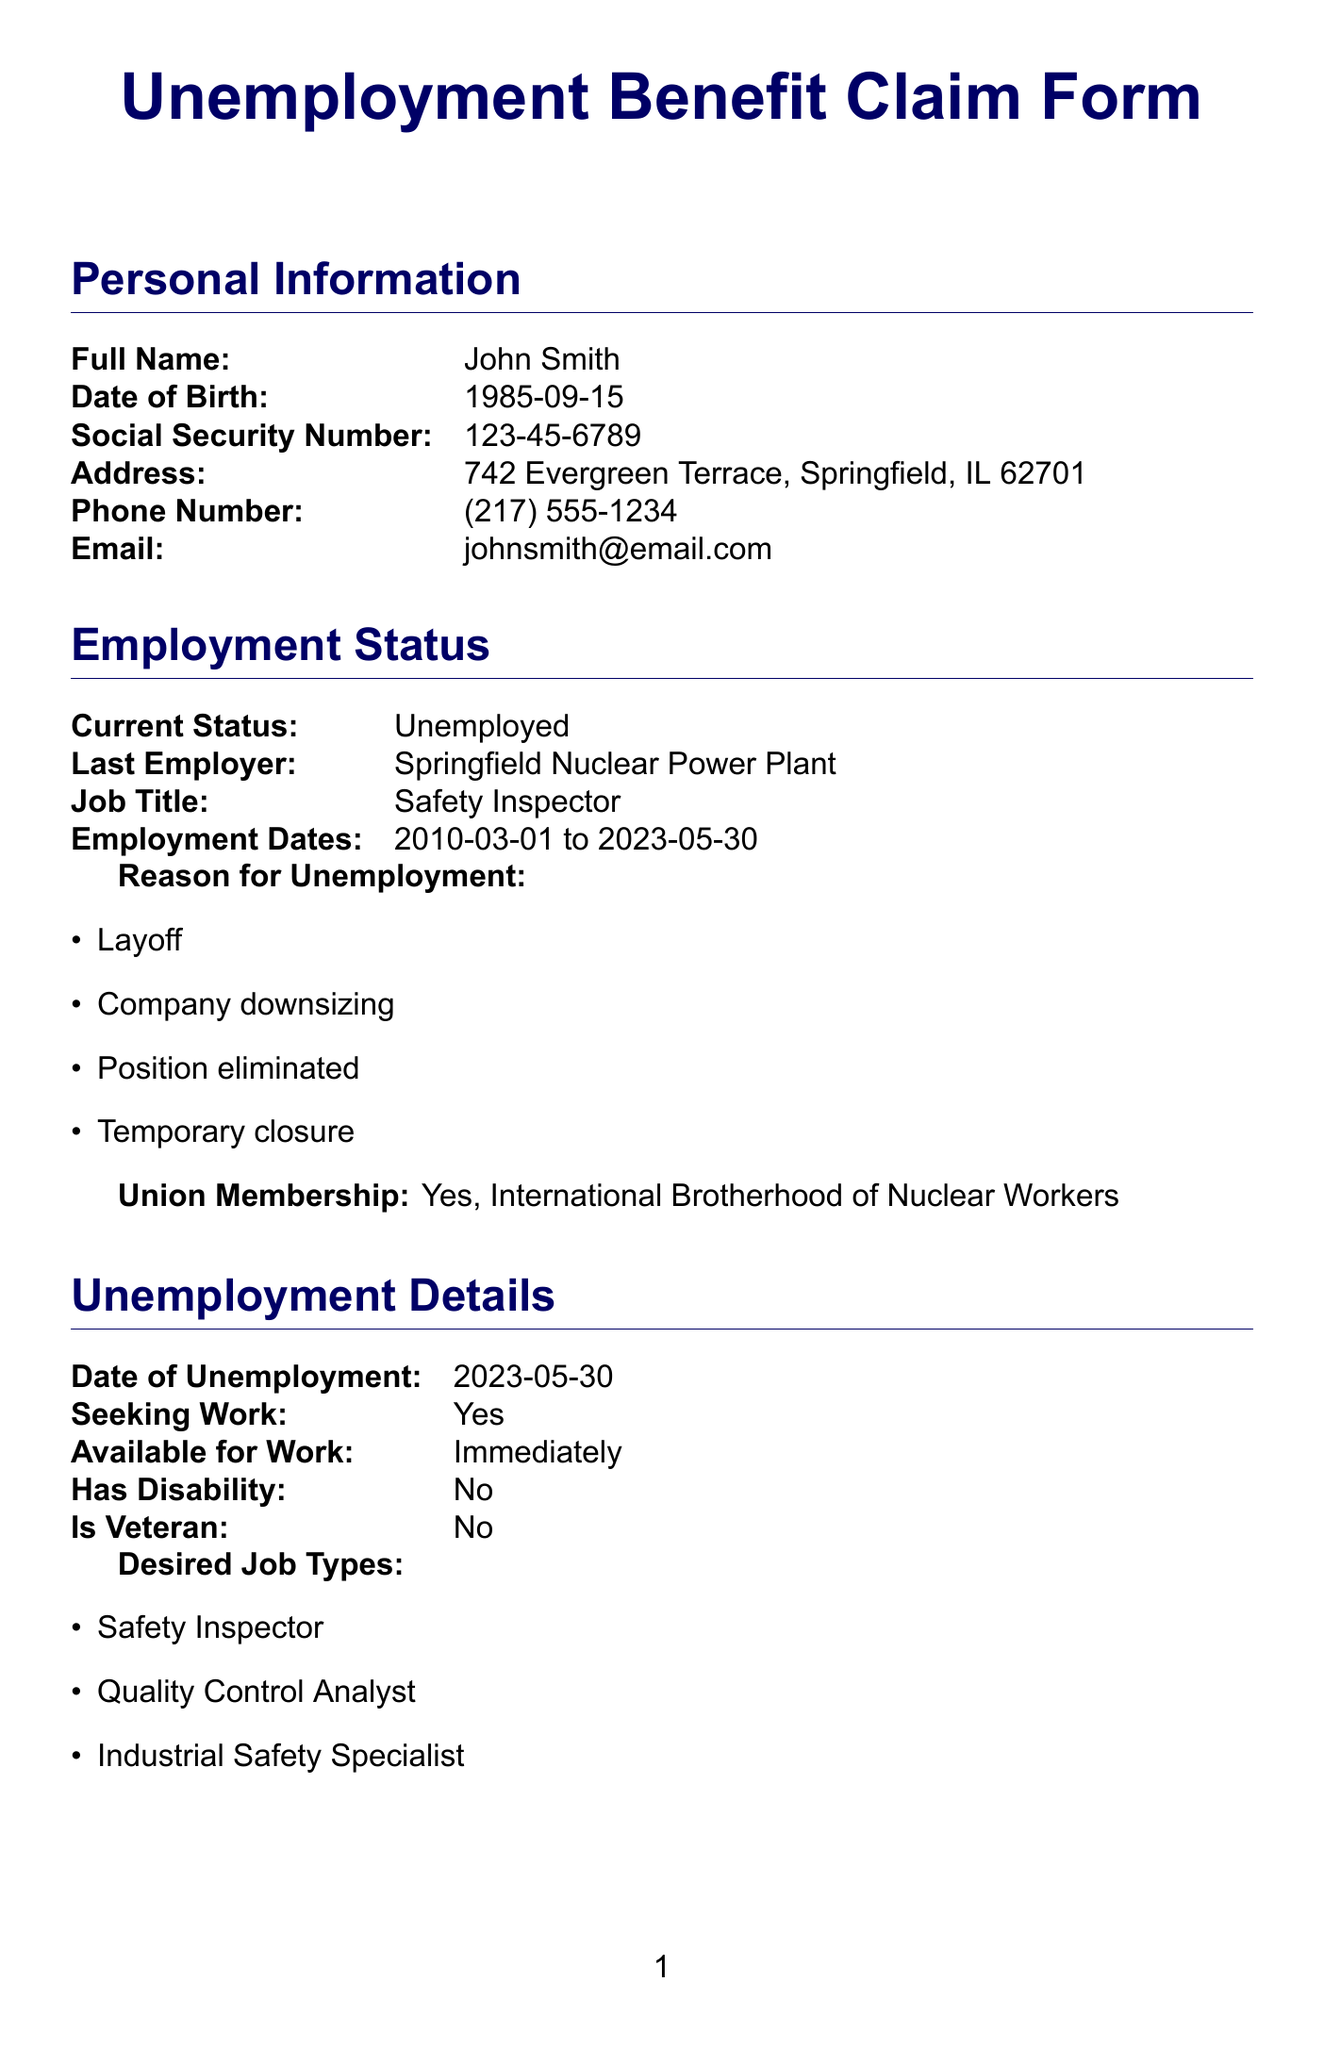what is the full name of the claimant? The full name is listed in the personal information section of the document.
Answer: John Smith what is the date of birth of the claimant? The date of birth can be found in the personal information section.
Answer: 1985-09-15 what is the last employer's name? The name of the last employer can be found in the employment status section.
Answer: Springfield Nuclear Power Plant what is the reason for unemployment? The reasons for unemployment are listed under the employment status section.
Answer: Layoff what is the date of unemployment? The date when the individual became unemployed is specified in the unemployment details section.
Answer: 2023-05-30 is the claimant a union member? Union membership status is detailed in the employment status section of the document.
Answer: Yes what job types is the claimant seeking? The desired job types are listed in the unemployment details section.
Answer: Safety Inspector is the claimant willing to relocate? Willingness to relocate is included in the additional questions section.
Answer: Yes how many supporting documents are attached? The supporting documents are enumerated in the supporting documents section of the document.
Answer: Five 